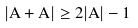<formula> <loc_0><loc_0><loc_500><loc_500>| A + A | \geq 2 | A | - 1</formula> 